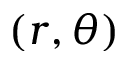<formula> <loc_0><loc_0><loc_500><loc_500>( r , \theta )</formula> 